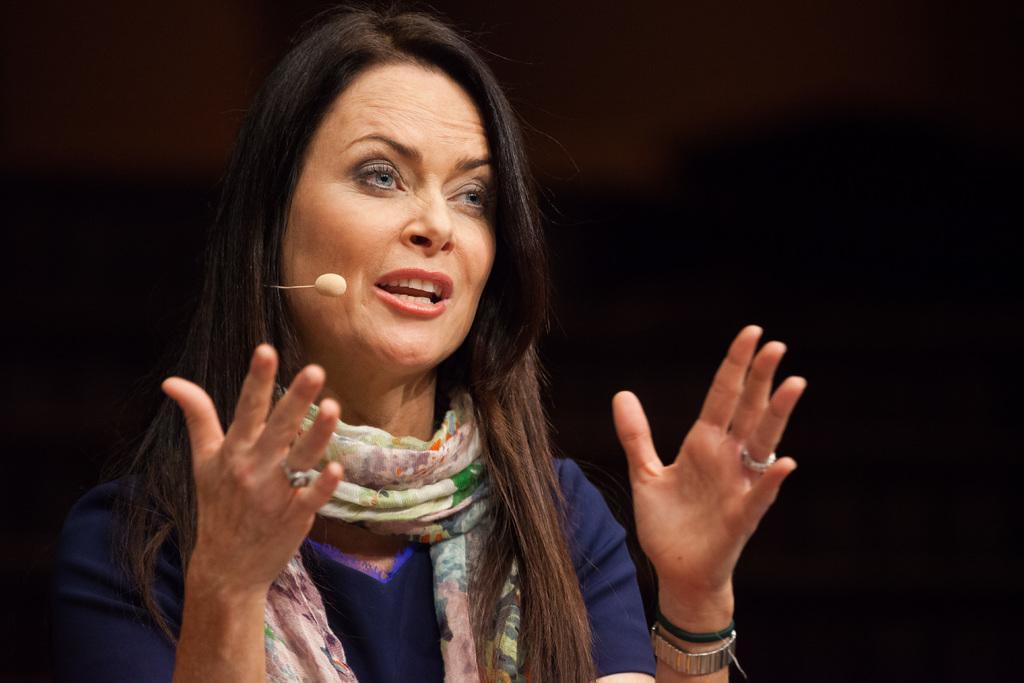How would you summarize this image in a sentence or two? In the image we can see there is a lady and she is wearing scarf. There is a mouth mic. 